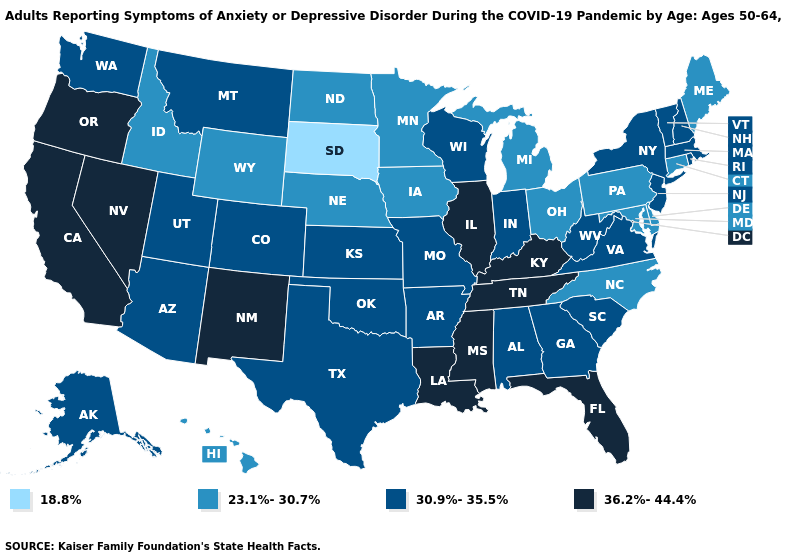What is the value of Hawaii?
Quick response, please. 23.1%-30.7%. Does Delaware have a lower value than Maryland?
Quick response, please. No. Which states have the lowest value in the South?
Give a very brief answer. Delaware, Maryland, North Carolina. Does Minnesota have a lower value than Alabama?
Write a very short answer. Yes. Name the states that have a value in the range 23.1%-30.7%?
Write a very short answer. Connecticut, Delaware, Hawaii, Idaho, Iowa, Maine, Maryland, Michigan, Minnesota, Nebraska, North Carolina, North Dakota, Ohio, Pennsylvania, Wyoming. Name the states that have a value in the range 36.2%-44.4%?
Short answer required. California, Florida, Illinois, Kentucky, Louisiana, Mississippi, Nevada, New Mexico, Oregon, Tennessee. Among the states that border Colorado , does New Mexico have the highest value?
Short answer required. Yes. What is the lowest value in states that border New Jersey?
Quick response, please. 23.1%-30.7%. How many symbols are there in the legend?
Keep it brief. 4. Does the map have missing data?
Answer briefly. No. Which states have the highest value in the USA?
Short answer required. California, Florida, Illinois, Kentucky, Louisiana, Mississippi, Nevada, New Mexico, Oregon, Tennessee. What is the lowest value in the MidWest?
Write a very short answer. 18.8%. What is the value of South Carolina?
Short answer required. 30.9%-35.5%. What is the value of Maryland?
Concise answer only. 23.1%-30.7%. What is the highest value in the USA?
Quick response, please. 36.2%-44.4%. 